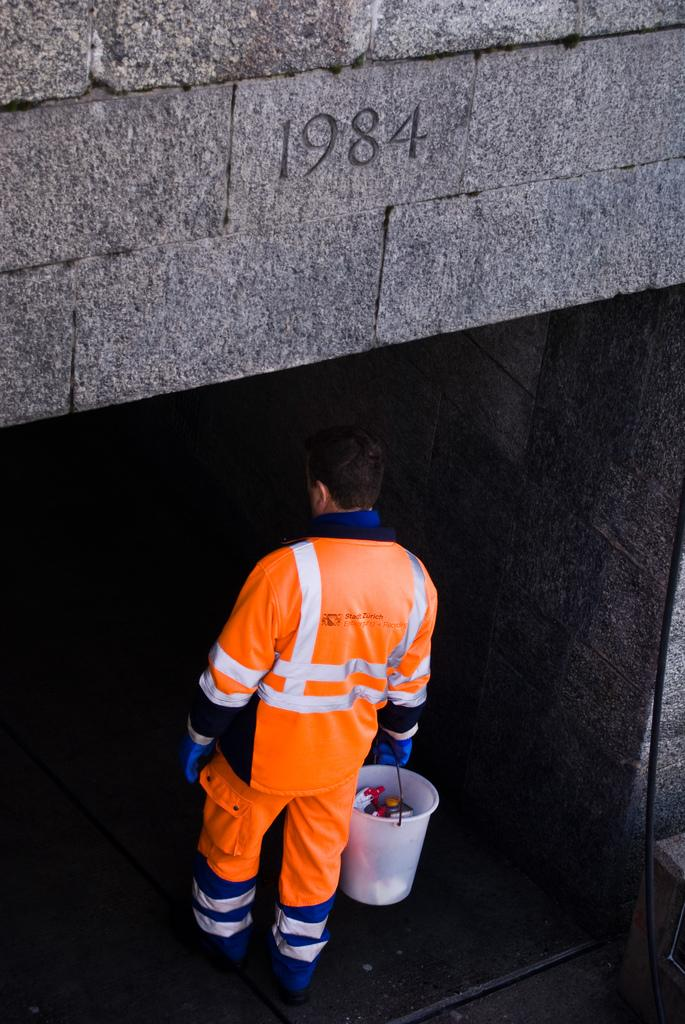<image>
Present a compact description of the photo's key features. A man walking into a building with 1984 above his head carrying a bucket. 